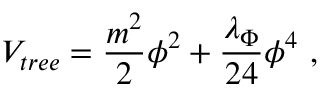<formula> <loc_0><loc_0><loc_500><loc_500>V _ { t r e e } = { \frac { m ^ { 2 } } { 2 } } \phi ^ { 2 } + { \frac { \lambda _ { \Phi } } { 2 4 } } \phi ^ { 4 } ,</formula> 